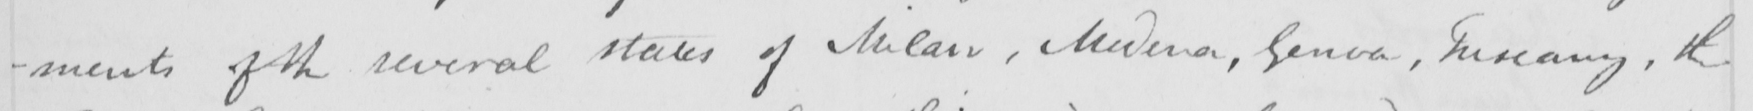Please transcribe the handwritten text in this image. -ments of the several states of Milan , Modena , Genoa , Tuscany , the 